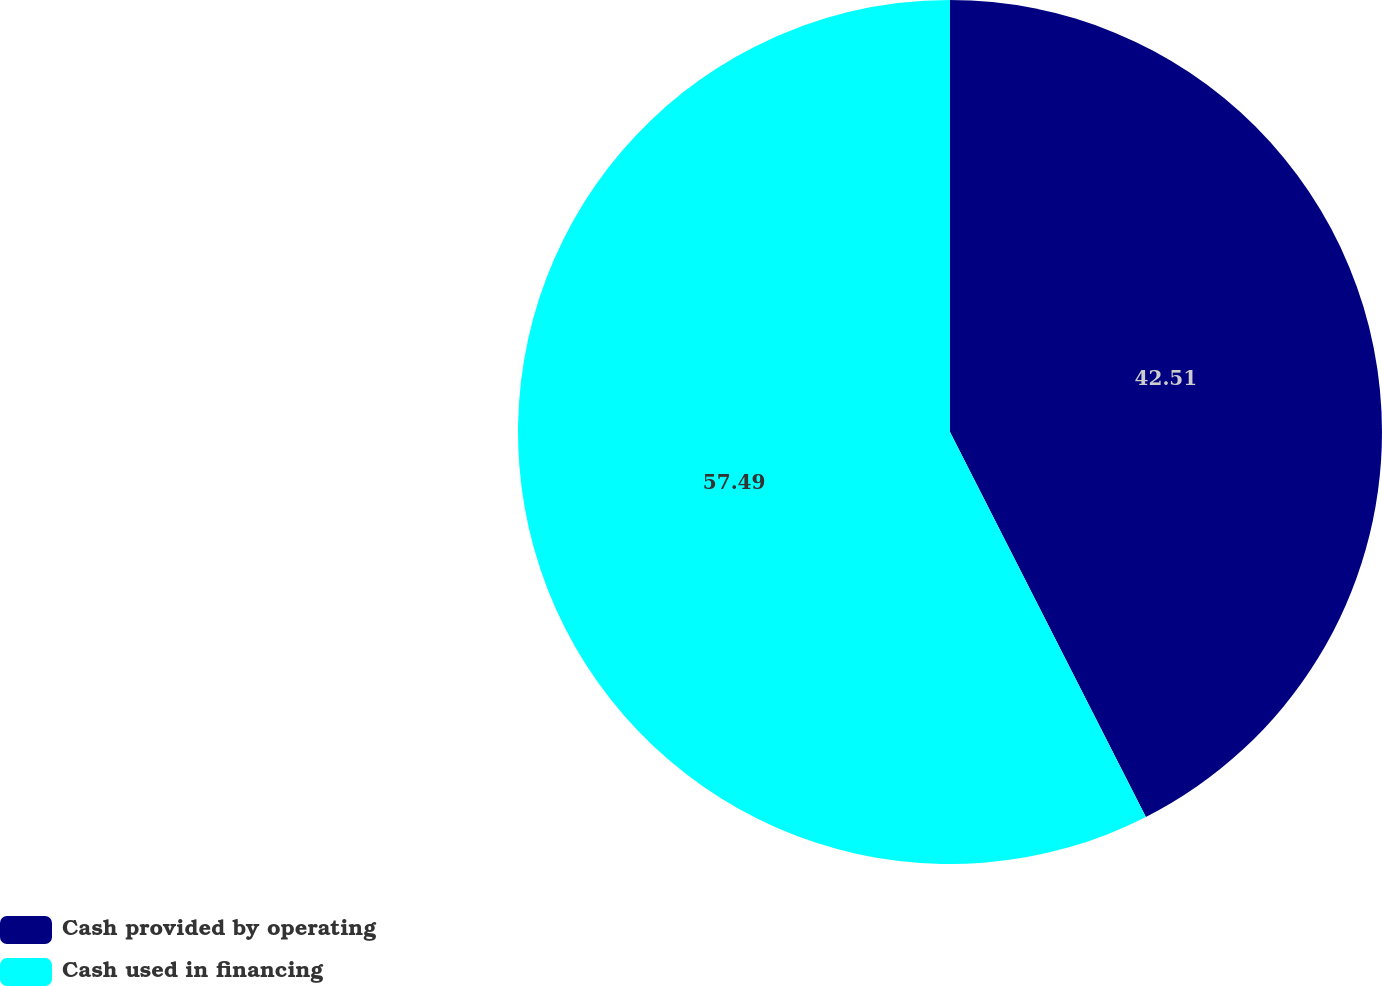Convert chart to OTSL. <chart><loc_0><loc_0><loc_500><loc_500><pie_chart><fcel>Cash provided by operating<fcel>Cash used in financing<nl><fcel>42.51%<fcel>57.49%<nl></chart> 